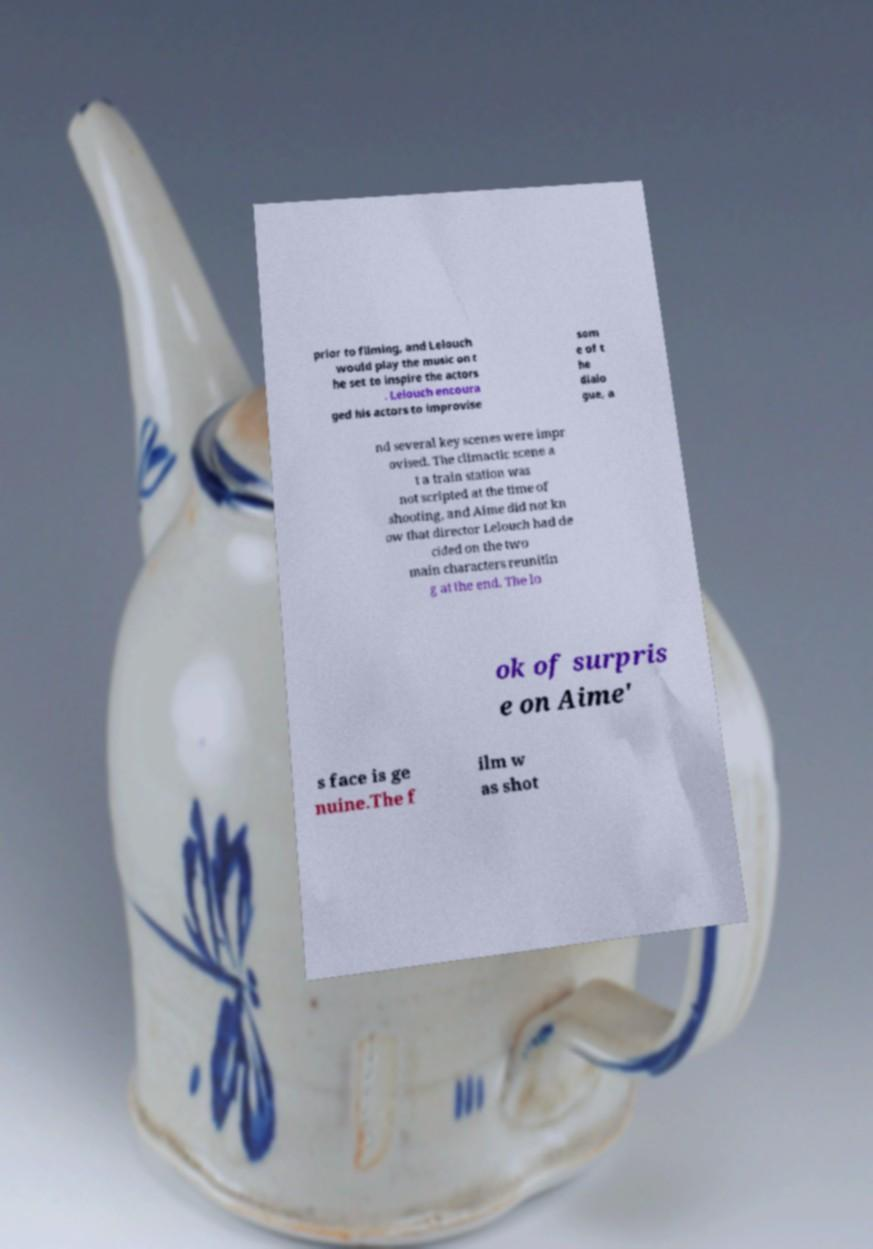I need the written content from this picture converted into text. Can you do that? prior to filming, and Lelouch would play the music on t he set to inspire the actors . Lelouch encoura ged his actors to improvise som e of t he dialo gue, a nd several key scenes were impr ovised. The climactic scene a t a train station was not scripted at the time of shooting, and Aime did not kn ow that director Lelouch had de cided on the two main characters reunitin g at the end. The lo ok of surpris e on Aime' s face is ge nuine.The f ilm w as shot 